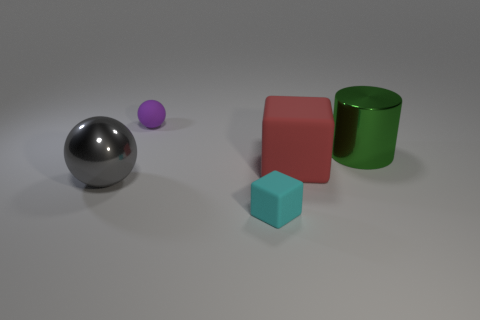What shape is the big thing behind the red matte object? The large object behind the red matte cube is a cylinder. It has a circular base and appears to be green with a smooth and glossy surface, consistent with attributes of a typical cylindrical shape. 